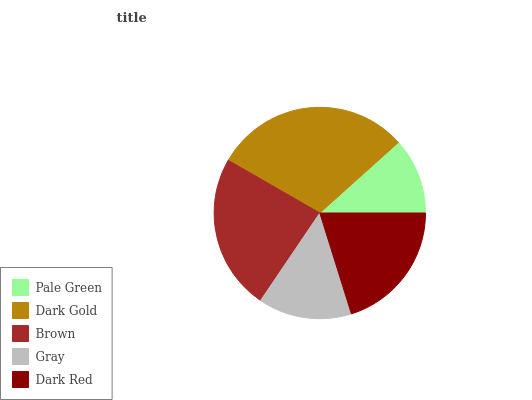Is Pale Green the minimum?
Answer yes or no. Yes. Is Dark Gold the maximum?
Answer yes or no. Yes. Is Brown the minimum?
Answer yes or no. No. Is Brown the maximum?
Answer yes or no. No. Is Dark Gold greater than Brown?
Answer yes or no. Yes. Is Brown less than Dark Gold?
Answer yes or no. Yes. Is Brown greater than Dark Gold?
Answer yes or no. No. Is Dark Gold less than Brown?
Answer yes or no. No. Is Dark Red the high median?
Answer yes or no. Yes. Is Dark Red the low median?
Answer yes or no. Yes. Is Dark Gold the high median?
Answer yes or no. No. Is Dark Gold the low median?
Answer yes or no. No. 